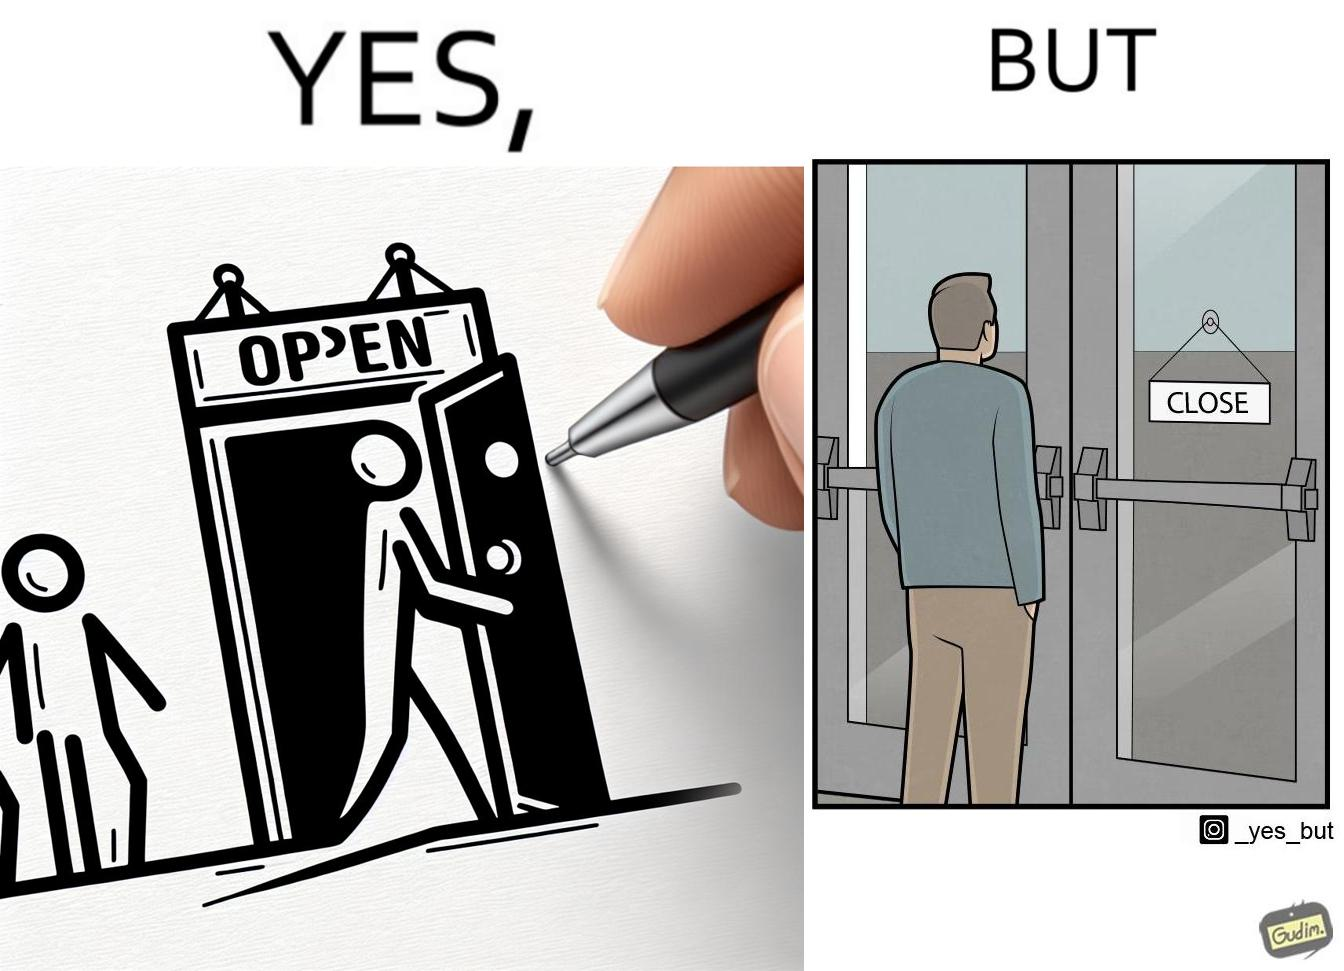Describe the satirical element in this image. The image is funny because a person opens a door with the sign 'OPEN', meaning the place is open. However, once the person enters the building and looks back, the other side of the sign reads 'CLOSE', which ideally should not be the case, as the place is actually open. 